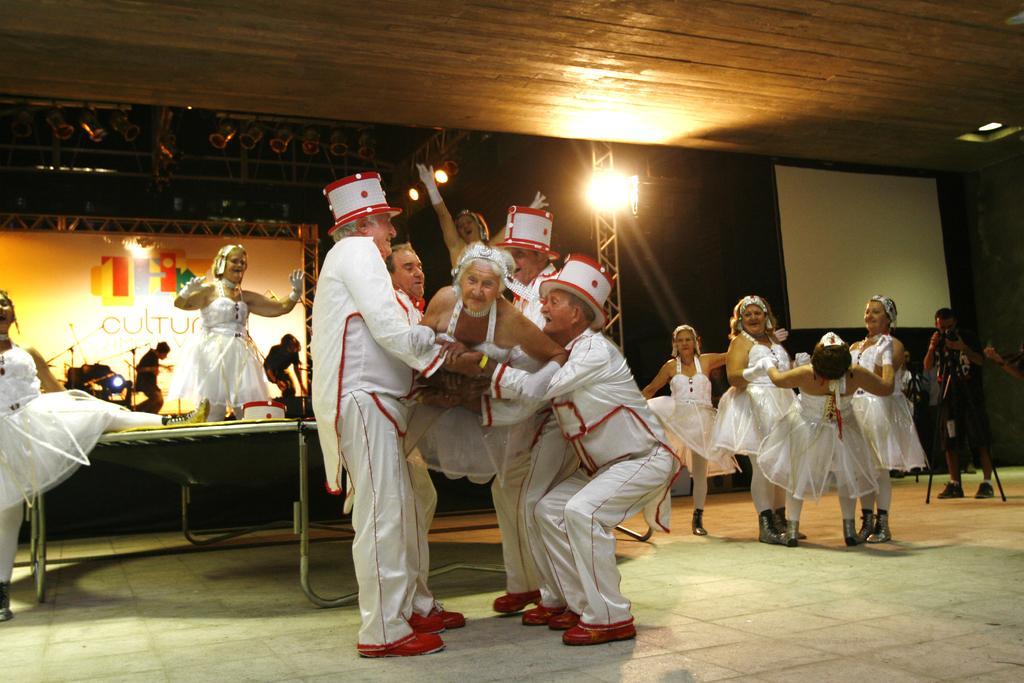How would you summarize this image in a sentence or two? In this image I can see number of people are standing. I can see all of them are wearing white colour dress and few of them are wearing white colour hats. I can also see few men are are holding a woman. In the background I can see few boards, number of lights and on one board I can see something is written. 